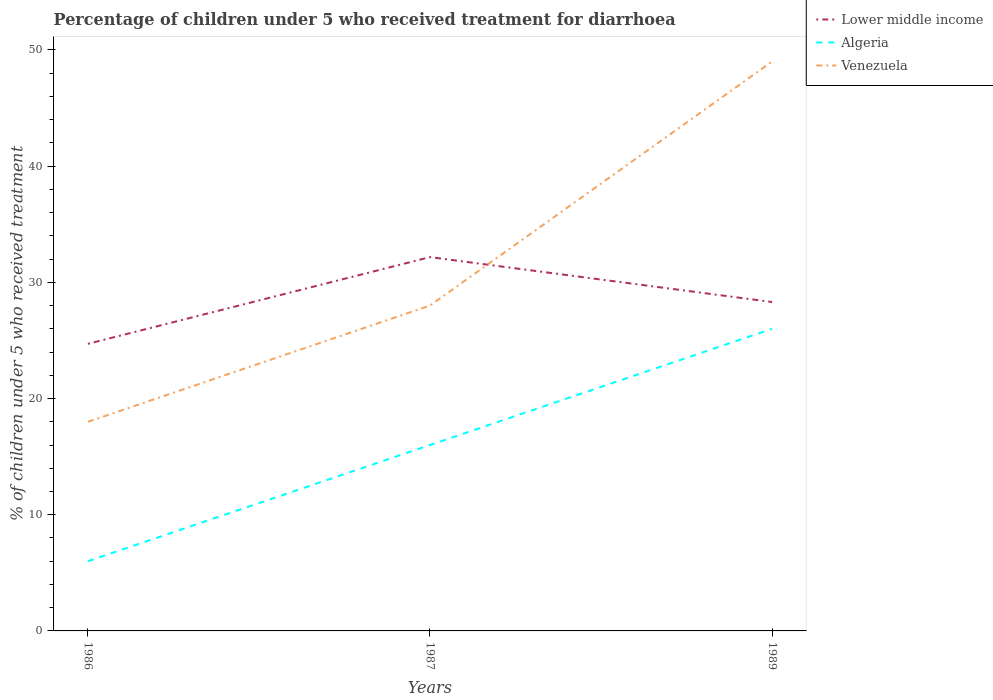How many different coloured lines are there?
Your response must be concise. 3. Does the line corresponding to Venezuela intersect with the line corresponding to Lower middle income?
Keep it short and to the point. Yes. Is the number of lines equal to the number of legend labels?
Make the answer very short. Yes. Across all years, what is the maximum percentage of children who received treatment for diarrhoea  in Algeria?
Your answer should be compact. 6. What is the total percentage of children who received treatment for diarrhoea  in Lower middle income in the graph?
Provide a short and direct response. -7.46. What is the difference between the highest and the second highest percentage of children who received treatment for diarrhoea  in Algeria?
Offer a very short reply. 20. What is the difference between the highest and the lowest percentage of children who received treatment for diarrhoea  in Lower middle income?
Give a very brief answer. 1. Is the percentage of children who received treatment for diarrhoea  in Venezuela strictly greater than the percentage of children who received treatment for diarrhoea  in Algeria over the years?
Ensure brevity in your answer.  No. How many years are there in the graph?
Ensure brevity in your answer.  3. Are the values on the major ticks of Y-axis written in scientific E-notation?
Keep it short and to the point. No. Does the graph contain any zero values?
Give a very brief answer. No. Does the graph contain grids?
Offer a terse response. No. How many legend labels are there?
Your answer should be compact. 3. How are the legend labels stacked?
Your response must be concise. Vertical. What is the title of the graph?
Your answer should be very brief. Percentage of children under 5 who received treatment for diarrhoea. What is the label or title of the X-axis?
Offer a very short reply. Years. What is the label or title of the Y-axis?
Make the answer very short. % of children under 5 who received treatment. What is the % of children under 5 who received treatment of Lower middle income in 1986?
Provide a short and direct response. 24.71. What is the % of children under 5 who received treatment of Lower middle income in 1987?
Keep it short and to the point. 32.17. What is the % of children under 5 who received treatment of Algeria in 1987?
Offer a terse response. 16. What is the % of children under 5 who received treatment of Venezuela in 1987?
Ensure brevity in your answer.  28. What is the % of children under 5 who received treatment in Lower middle income in 1989?
Offer a terse response. 28.31. What is the % of children under 5 who received treatment in Venezuela in 1989?
Make the answer very short. 49. Across all years, what is the maximum % of children under 5 who received treatment of Lower middle income?
Your answer should be very brief. 32.17. Across all years, what is the minimum % of children under 5 who received treatment in Lower middle income?
Your response must be concise. 24.71. Across all years, what is the minimum % of children under 5 who received treatment of Algeria?
Keep it short and to the point. 6. What is the total % of children under 5 who received treatment in Lower middle income in the graph?
Your response must be concise. 85.19. What is the difference between the % of children under 5 who received treatment in Lower middle income in 1986 and that in 1987?
Provide a short and direct response. -7.46. What is the difference between the % of children under 5 who received treatment in Lower middle income in 1986 and that in 1989?
Your answer should be compact. -3.6. What is the difference between the % of children under 5 who received treatment in Venezuela in 1986 and that in 1989?
Offer a terse response. -31. What is the difference between the % of children under 5 who received treatment in Lower middle income in 1987 and that in 1989?
Offer a terse response. 3.86. What is the difference between the % of children under 5 who received treatment in Venezuela in 1987 and that in 1989?
Your response must be concise. -21. What is the difference between the % of children under 5 who received treatment in Lower middle income in 1986 and the % of children under 5 who received treatment in Algeria in 1987?
Keep it short and to the point. 8.71. What is the difference between the % of children under 5 who received treatment in Lower middle income in 1986 and the % of children under 5 who received treatment in Venezuela in 1987?
Provide a short and direct response. -3.29. What is the difference between the % of children under 5 who received treatment in Lower middle income in 1986 and the % of children under 5 who received treatment in Algeria in 1989?
Ensure brevity in your answer.  -1.29. What is the difference between the % of children under 5 who received treatment of Lower middle income in 1986 and the % of children under 5 who received treatment of Venezuela in 1989?
Make the answer very short. -24.29. What is the difference between the % of children under 5 who received treatment of Algeria in 1986 and the % of children under 5 who received treatment of Venezuela in 1989?
Offer a terse response. -43. What is the difference between the % of children under 5 who received treatment in Lower middle income in 1987 and the % of children under 5 who received treatment in Algeria in 1989?
Ensure brevity in your answer.  6.17. What is the difference between the % of children under 5 who received treatment in Lower middle income in 1987 and the % of children under 5 who received treatment in Venezuela in 1989?
Make the answer very short. -16.83. What is the difference between the % of children under 5 who received treatment in Algeria in 1987 and the % of children under 5 who received treatment in Venezuela in 1989?
Provide a succinct answer. -33. What is the average % of children under 5 who received treatment in Lower middle income per year?
Keep it short and to the point. 28.4. What is the average % of children under 5 who received treatment of Venezuela per year?
Your answer should be very brief. 31.67. In the year 1986, what is the difference between the % of children under 5 who received treatment in Lower middle income and % of children under 5 who received treatment in Algeria?
Make the answer very short. 18.71. In the year 1986, what is the difference between the % of children under 5 who received treatment in Lower middle income and % of children under 5 who received treatment in Venezuela?
Your answer should be very brief. 6.71. In the year 1987, what is the difference between the % of children under 5 who received treatment in Lower middle income and % of children under 5 who received treatment in Algeria?
Give a very brief answer. 16.17. In the year 1987, what is the difference between the % of children under 5 who received treatment of Lower middle income and % of children under 5 who received treatment of Venezuela?
Provide a short and direct response. 4.17. In the year 1989, what is the difference between the % of children under 5 who received treatment of Lower middle income and % of children under 5 who received treatment of Algeria?
Ensure brevity in your answer.  2.31. In the year 1989, what is the difference between the % of children under 5 who received treatment in Lower middle income and % of children under 5 who received treatment in Venezuela?
Your answer should be very brief. -20.69. What is the ratio of the % of children under 5 who received treatment in Lower middle income in 1986 to that in 1987?
Your response must be concise. 0.77. What is the ratio of the % of children under 5 who received treatment in Venezuela in 1986 to that in 1987?
Provide a succinct answer. 0.64. What is the ratio of the % of children under 5 who received treatment of Lower middle income in 1986 to that in 1989?
Offer a terse response. 0.87. What is the ratio of the % of children under 5 who received treatment of Algeria in 1986 to that in 1989?
Ensure brevity in your answer.  0.23. What is the ratio of the % of children under 5 who received treatment of Venezuela in 1986 to that in 1989?
Offer a terse response. 0.37. What is the ratio of the % of children under 5 who received treatment of Lower middle income in 1987 to that in 1989?
Keep it short and to the point. 1.14. What is the ratio of the % of children under 5 who received treatment in Algeria in 1987 to that in 1989?
Give a very brief answer. 0.62. What is the ratio of the % of children under 5 who received treatment of Venezuela in 1987 to that in 1989?
Keep it short and to the point. 0.57. What is the difference between the highest and the second highest % of children under 5 who received treatment of Lower middle income?
Your answer should be very brief. 3.86. What is the difference between the highest and the second highest % of children under 5 who received treatment in Venezuela?
Make the answer very short. 21. What is the difference between the highest and the lowest % of children under 5 who received treatment in Lower middle income?
Your response must be concise. 7.46. What is the difference between the highest and the lowest % of children under 5 who received treatment of Venezuela?
Your response must be concise. 31. 